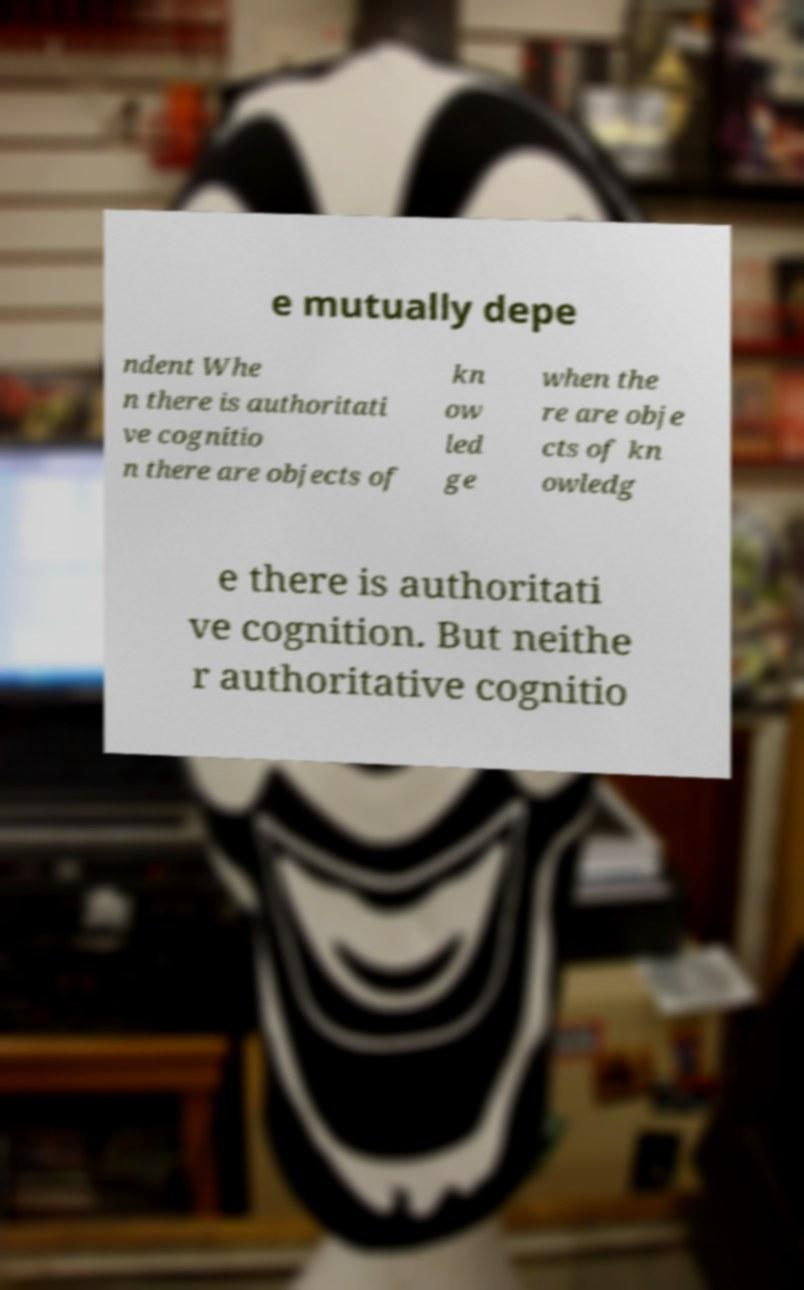Could you extract and type out the text from this image? e mutually depe ndent Whe n there is authoritati ve cognitio n there are objects of kn ow led ge when the re are obje cts of kn owledg e there is authoritati ve cognition. But neithe r authoritative cognitio 